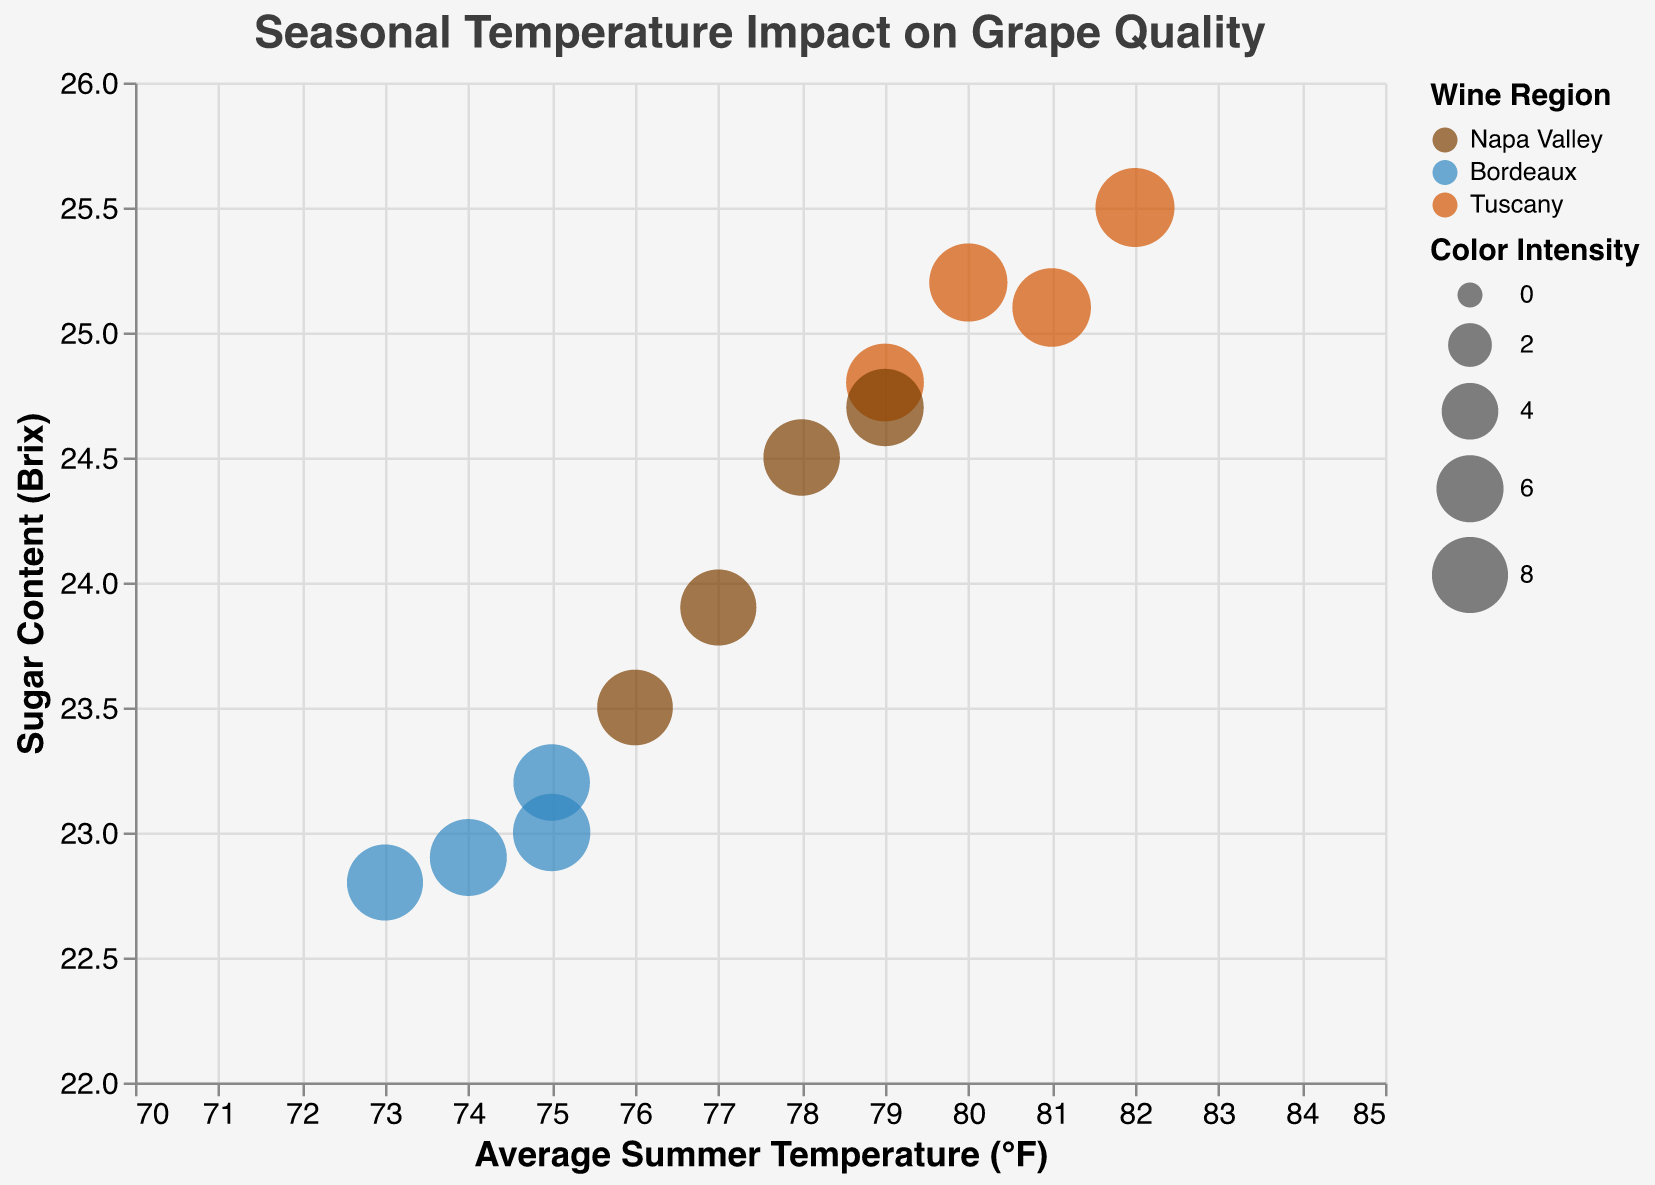What is the title of the chart? The title is prominently displayed at the top of the chart, indicating the main focus.
Answer: Seasonal Temperature Impact on Grape Quality Which region exhibited the highest sugar content in 2020? By observing the y-axis (Sugar Content Brix) and filtering for data points from 2020, the highest point corresponds to Tuscany.
Answer: Tuscany Between Napa Valley and Bordeaux in 2021, which region had higher color intensity? We compare the size of the bubbles corresponding to Napa Valley and Bordeaux in 2021; the larger bubble indicates higher color intensity.
Answer: Napa Valley How does the average summer temperature in 2019 compare between Napa Valley and Bordeaux? Inspecting the x-axis for data points in 2019 for both regions shows Napa Valley has a higher average summer temperature.
Answer: Napa Valley What is the average sugar content for Tuscany across all years? Taking the data points for Tuscany, the sugar content values are 25.2, 24.8, 25.1, and 25.5; the average is calculated by summing these values and dividing by the number of data points. (25.2 + 24.8 + 25.1 + 25.5) / 4 = 25.15
Answer: 25.15 Which year showed the highest average color intensity regardless of region? Evaluating the size of the bubbles for each year, 2021 has the largest-sized bubbles indicating the highest average color intensity.
Answer: 2021 Is there a correlation between average summer temperature and sugar content? Observing the trend on the x-axis and y-axis, higher average summer temperatures generally correspond to higher sugar content, suggesting a positive correlation.
Answer: Positive correlation Identify the region with the lowest acidity (pH) in 2019. By checking the tooltip information for the year 2019 and comparing the acidity values, Bordeaux has the lowest acidity.
Answer: Bordeaux Between 2018 to 2021, which region consistently showed the highest sugar content? Reviewing the data points over the years, Tuscany consistently falls on the highest points on the y-axis.
Answer: Tuscany 